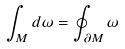Convert formula to latex. <formula><loc_0><loc_0><loc_500><loc_500>\int _ { M } d \omega = \oint _ { \partial M } \omega</formula> 